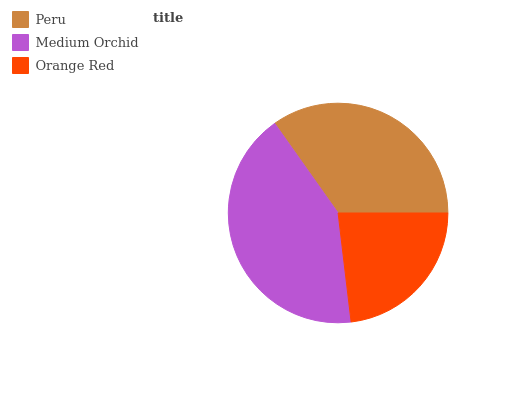Is Orange Red the minimum?
Answer yes or no. Yes. Is Medium Orchid the maximum?
Answer yes or no. Yes. Is Medium Orchid the minimum?
Answer yes or no. No. Is Orange Red the maximum?
Answer yes or no. No. Is Medium Orchid greater than Orange Red?
Answer yes or no. Yes. Is Orange Red less than Medium Orchid?
Answer yes or no. Yes. Is Orange Red greater than Medium Orchid?
Answer yes or no. No. Is Medium Orchid less than Orange Red?
Answer yes or no. No. Is Peru the high median?
Answer yes or no. Yes. Is Peru the low median?
Answer yes or no. Yes. Is Medium Orchid the high median?
Answer yes or no. No. Is Medium Orchid the low median?
Answer yes or no. No. 